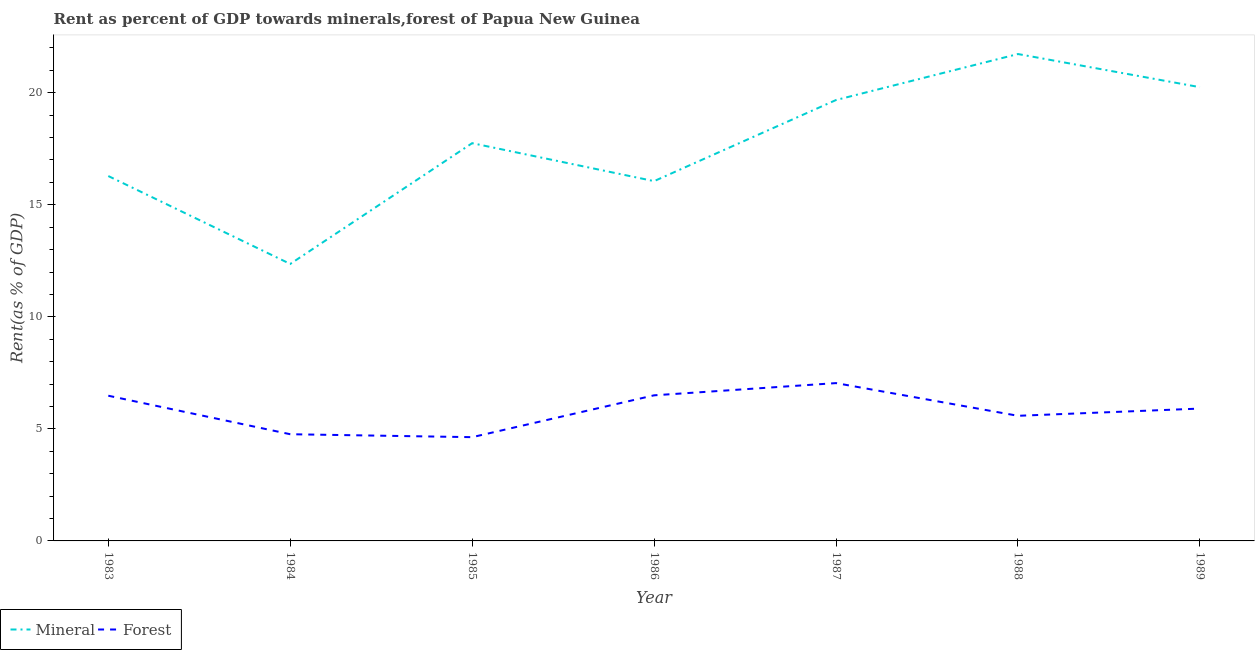How many different coloured lines are there?
Provide a succinct answer. 2. Does the line corresponding to mineral rent intersect with the line corresponding to forest rent?
Your response must be concise. No. Is the number of lines equal to the number of legend labels?
Your response must be concise. Yes. What is the forest rent in 1988?
Give a very brief answer. 5.58. Across all years, what is the maximum mineral rent?
Your answer should be compact. 21.73. Across all years, what is the minimum forest rent?
Give a very brief answer. 4.63. In which year was the mineral rent minimum?
Ensure brevity in your answer.  1984. What is the total mineral rent in the graph?
Offer a very short reply. 124.1. What is the difference between the mineral rent in 1985 and that in 1988?
Make the answer very short. -3.98. What is the difference between the forest rent in 1989 and the mineral rent in 1984?
Your answer should be compact. -6.45. What is the average mineral rent per year?
Your response must be concise. 17.73. In the year 1983, what is the difference between the forest rent and mineral rent?
Provide a succinct answer. -9.8. In how many years, is the forest rent greater than 6 %?
Ensure brevity in your answer.  3. What is the ratio of the forest rent in 1988 to that in 1989?
Ensure brevity in your answer.  0.95. What is the difference between the highest and the second highest mineral rent?
Provide a short and direct response. 1.48. What is the difference between the highest and the lowest mineral rent?
Offer a very short reply. 9.37. Does the forest rent monotonically increase over the years?
Make the answer very short. No. Is the forest rent strictly greater than the mineral rent over the years?
Offer a very short reply. No. Is the forest rent strictly less than the mineral rent over the years?
Give a very brief answer. Yes. How many lines are there?
Make the answer very short. 2. How many years are there in the graph?
Your answer should be very brief. 7. What is the difference between two consecutive major ticks on the Y-axis?
Make the answer very short. 5. Are the values on the major ticks of Y-axis written in scientific E-notation?
Keep it short and to the point. No. Does the graph contain grids?
Make the answer very short. No. Where does the legend appear in the graph?
Provide a short and direct response. Bottom left. How many legend labels are there?
Give a very brief answer. 2. What is the title of the graph?
Your response must be concise. Rent as percent of GDP towards minerals,forest of Papua New Guinea. What is the label or title of the X-axis?
Offer a terse response. Year. What is the label or title of the Y-axis?
Ensure brevity in your answer.  Rent(as % of GDP). What is the Rent(as % of GDP) in Mineral in 1983?
Give a very brief answer. 16.28. What is the Rent(as % of GDP) in Forest in 1983?
Ensure brevity in your answer.  6.48. What is the Rent(as % of GDP) of Mineral in 1984?
Give a very brief answer. 12.36. What is the Rent(as % of GDP) of Forest in 1984?
Ensure brevity in your answer.  4.76. What is the Rent(as % of GDP) in Mineral in 1985?
Offer a very short reply. 17.75. What is the Rent(as % of GDP) in Forest in 1985?
Offer a terse response. 4.63. What is the Rent(as % of GDP) of Mineral in 1986?
Make the answer very short. 16.05. What is the Rent(as % of GDP) of Forest in 1986?
Provide a succinct answer. 6.5. What is the Rent(as % of GDP) of Mineral in 1987?
Your answer should be compact. 19.68. What is the Rent(as % of GDP) in Forest in 1987?
Offer a terse response. 7.04. What is the Rent(as % of GDP) of Mineral in 1988?
Your response must be concise. 21.73. What is the Rent(as % of GDP) in Forest in 1988?
Your response must be concise. 5.58. What is the Rent(as % of GDP) in Mineral in 1989?
Ensure brevity in your answer.  20.25. What is the Rent(as % of GDP) in Forest in 1989?
Offer a very short reply. 5.91. Across all years, what is the maximum Rent(as % of GDP) in Mineral?
Make the answer very short. 21.73. Across all years, what is the maximum Rent(as % of GDP) in Forest?
Make the answer very short. 7.04. Across all years, what is the minimum Rent(as % of GDP) of Mineral?
Your answer should be compact. 12.36. Across all years, what is the minimum Rent(as % of GDP) in Forest?
Offer a terse response. 4.63. What is the total Rent(as % of GDP) of Mineral in the graph?
Provide a succinct answer. 124.1. What is the total Rent(as % of GDP) of Forest in the graph?
Make the answer very short. 40.9. What is the difference between the Rent(as % of GDP) in Mineral in 1983 and that in 1984?
Offer a terse response. 3.92. What is the difference between the Rent(as % of GDP) of Forest in 1983 and that in 1984?
Ensure brevity in your answer.  1.72. What is the difference between the Rent(as % of GDP) in Mineral in 1983 and that in 1985?
Your answer should be very brief. -1.47. What is the difference between the Rent(as % of GDP) in Forest in 1983 and that in 1985?
Keep it short and to the point. 1.85. What is the difference between the Rent(as % of GDP) of Mineral in 1983 and that in 1986?
Provide a succinct answer. 0.23. What is the difference between the Rent(as % of GDP) of Forest in 1983 and that in 1986?
Give a very brief answer. -0.02. What is the difference between the Rent(as % of GDP) in Mineral in 1983 and that in 1987?
Your answer should be compact. -3.39. What is the difference between the Rent(as % of GDP) of Forest in 1983 and that in 1987?
Make the answer very short. -0.56. What is the difference between the Rent(as % of GDP) in Mineral in 1983 and that in 1988?
Make the answer very short. -5.44. What is the difference between the Rent(as % of GDP) in Forest in 1983 and that in 1988?
Provide a succinct answer. 0.9. What is the difference between the Rent(as % of GDP) in Mineral in 1983 and that in 1989?
Keep it short and to the point. -3.96. What is the difference between the Rent(as % of GDP) in Forest in 1983 and that in 1989?
Make the answer very short. 0.57. What is the difference between the Rent(as % of GDP) in Mineral in 1984 and that in 1985?
Your answer should be compact. -5.39. What is the difference between the Rent(as % of GDP) in Forest in 1984 and that in 1985?
Provide a short and direct response. 0.13. What is the difference between the Rent(as % of GDP) in Mineral in 1984 and that in 1986?
Offer a terse response. -3.7. What is the difference between the Rent(as % of GDP) in Forest in 1984 and that in 1986?
Keep it short and to the point. -1.74. What is the difference between the Rent(as % of GDP) of Mineral in 1984 and that in 1987?
Provide a short and direct response. -7.32. What is the difference between the Rent(as % of GDP) of Forest in 1984 and that in 1987?
Provide a succinct answer. -2.28. What is the difference between the Rent(as % of GDP) in Mineral in 1984 and that in 1988?
Offer a very short reply. -9.37. What is the difference between the Rent(as % of GDP) in Forest in 1984 and that in 1988?
Offer a terse response. -0.82. What is the difference between the Rent(as % of GDP) of Mineral in 1984 and that in 1989?
Make the answer very short. -7.89. What is the difference between the Rent(as % of GDP) in Forest in 1984 and that in 1989?
Your answer should be compact. -1.14. What is the difference between the Rent(as % of GDP) in Mineral in 1985 and that in 1986?
Your answer should be very brief. 1.69. What is the difference between the Rent(as % of GDP) of Forest in 1985 and that in 1986?
Provide a short and direct response. -1.87. What is the difference between the Rent(as % of GDP) in Mineral in 1985 and that in 1987?
Ensure brevity in your answer.  -1.93. What is the difference between the Rent(as % of GDP) in Forest in 1985 and that in 1987?
Keep it short and to the point. -2.41. What is the difference between the Rent(as % of GDP) of Mineral in 1985 and that in 1988?
Your answer should be compact. -3.98. What is the difference between the Rent(as % of GDP) of Forest in 1985 and that in 1988?
Your answer should be very brief. -0.95. What is the difference between the Rent(as % of GDP) in Mineral in 1985 and that in 1989?
Provide a short and direct response. -2.5. What is the difference between the Rent(as % of GDP) of Forest in 1985 and that in 1989?
Ensure brevity in your answer.  -1.28. What is the difference between the Rent(as % of GDP) in Mineral in 1986 and that in 1987?
Give a very brief answer. -3.62. What is the difference between the Rent(as % of GDP) of Forest in 1986 and that in 1987?
Provide a succinct answer. -0.55. What is the difference between the Rent(as % of GDP) of Mineral in 1986 and that in 1988?
Ensure brevity in your answer.  -5.67. What is the difference between the Rent(as % of GDP) in Forest in 1986 and that in 1988?
Give a very brief answer. 0.91. What is the difference between the Rent(as % of GDP) of Mineral in 1986 and that in 1989?
Ensure brevity in your answer.  -4.19. What is the difference between the Rent(as % of GDP) in Forest in 1986 and that in 1989?
Your answer should be very brief. 0.59. What is the difference between the Rent(as % of GDP) in Mineral in 1987 and that in 1988?
Ensure brevity in your answer.  -2.05. What is the difference between the Rent(as % of GDP) of Forest in 1987 and that in 1988?
Offer a terse response. 1.46. What is the difference between the Rent(as % of GDP) in Mineral in 1987 and that in 1989?
Your answer should be compact. -0.57. What is the difference between the Rent(as % of GDP) of Forest in 1987 and that in 1989?
Ensure brevity in your answer.  1.14. What is the difference between the Rent(as % of GDP) in Mineral in 1988 and that in 1989?
Provide a succinct answer. 1.48. What is the difference between the Rent(as % of GDP) in Forest in 1988 and that in 1989?
Keep it short and to the point. -0.32. What is the difference between the Rent(as % of GDP) in Mineral in 1983 and the Rent(as % of GDP) in Forest in 1984?
Provide a succinct answer. 11.52. What is the difference between the Rent(as % of GDP) of Mineral in 1983 and the Rent(as % of GDP) of Forest in 1985?
Your answer should be compact. 11.65. What is the difference between the Rent(as % of GDP) in Mineral in 1983 and the Rent(as % of GDP) in Forest in 1986?
Your response must be concise. 9.79. What is the difference between the Rent(as % of GDP) of Mineral in 1983 and the Rent(as % of GDP) of Forest in 1987?
Offer a very short reply. 9.24. What is the difference between the Rent(as % of GDP) in Mineral in 1983 and the Rent(as % of GDP) in Forest in 1988?
Ensure brevity in your answer.  10.7. What is the difference between the Rent(as % of GDP) of Mineral in 1983 and the Rent(as % of GDP) of Forest in 1989?
Your answer should be very brief. 10.38. What is the difference between the Rent(as % of GDP) in Mineral in 1984 and the Rent(as % of GDP) in Forest in 1985?
Provide a succinct answer. 7.73. What is the difference between the Rent(as % of GDP) of Mineral in 1984 and the Rent(as % of GDP) of Forest in 1986?
Keep it short and to the point. 5.86. What is the difference between the Rent(as % of GDP) in Mineral in 1984 and the Rent(as % of GDP) in Forest in 1987?
Your answer should be compact. 5.32. What is the difference between the Rent(as % of GDP) of Mineral in 1984 and the Rent(as % of GDP) of Forest in 1988?
Your answer should be compact. 6.78. What is the difference between the Rent(as % of GDP) of Mineral in 1984 and the Rent(as % of GDP) of Forest in 1989?
Keep it short and to the point. 6.45. What is the difference between the Rent(as % of GDP) in Mineral in 1985 and the Rent(as % of GDP) in Forest in 1986?
Offer a terse response. 11.25. What is the difference between the Rent(as % of GDP) of Mineral in 1985 and the Rent(as % of GDP) of Forest in 1987?
Your answer should be compact. 10.71. What is the difference between the Rent(as % of GDP) in Mineral in 1985 and the Rent(as % of GDP) in Forest in 1988?
Keep it short and to the point. 12.17. What is the difference between the Rent(as % of GDP) of Mineral in 1985 and the Rent(as % of GDP) of Forest in 1989?
Offer a very short reply. 11.84. What is the difference between the Rent(as % of GDP) in Mineral in 1986 and the Rent(as % of GDP) in Forest in 1987?
Your response must be concise. 9.01. What is the difference between the Rent(as % of GDP) in Mineral in 1986 and the Rent(as % of GDP) in Forest in 1988?
Provide a short and direct response. 10.47. What is the difference between the Rent(as % of GDP) of Mineral in 1986 and the Rent(as % of GDP) of Forest in 1989?
Your response must be concise. 10.15. What is the difference between the Rent(as % of GDP) in Mineral in 1987 and the Rent(as % of GDP) in Forest in 1988?
Make the answer very short. 14.09. What is the difference between the Rent(as % of GDP) in Mineral in 1987 and the Rent(as % of GDP) in Forest in 1989?
Your answer should be compact. 13.77. What is the difference between the Rent(as % of GDP) of Mineral in 1988 and the Rent(as % of GDP) of Forest in 1989?
Keep it short and to the point. 15.82. What is the average Rent(as % of GDP) of Mineral per year?
Your answer should be very brief. 17.73. What is the average Rent(as % of GDP) of Forest per year?
Make the answer very short. 5.84. In the year 1983, what is the difference between the Rent(as % of GDP) of Mineral and Rent(as % of GDP) of Forest?
Offer a very short reply. 9.8. In the year 1984, what is the difference between the Rent(as % of GDP) of Mineral and Rent(as % of GDP) of Forest?
Ensure brevity in your answer.  7.6. In the year 1985, what is the difference between the Rent(as % of GDP) in Mineral and Rent(as % of GDP) in Forest?
Your answer should be compact. 13.12. In the year 1986, what is the difference between the Rent(as % of GDP) of Mineral and Rent(as % of GDP) of Forest?
Make the answer very short. 9.56. In the year 1987, what is the difference between the Rent(as % of GDP) of Mineral and Rent(as % of GDP) of Forest?
Your answer should be compact. 12.63. In the year 1988, what is the difference between the Rent(as % of GDP) in Mineral and Rent(as % of GDP) in Forest?
Your answer should be compact. 16.14. In the year 1989, what is the difference between the Rent(as % of GDP) of Mineral and Rent(as % of GDP) of Forest?
Ensure brevity in your answer.  14.34. What is the ratio of the Rent(as % of GDP) in Mineral in 1983 to that in 1984?
Your answer should be compact. 1.32. What is the ratio of the Rent(as % of GDP) in Forest in 1983 to that in 1984?
Provide a short and direct response. 1.36. What is the ratio of the Rent(as % of GDP) in Mineral in 1983 to that in 1985?
Your answer should be very brief. 0.92. What is the ratio of the Rent(as % of GDP) in Forest in 1983 to that in 1985?
Provide a short and direct response. 1.4. What is the ratio of the Rent(as % of GDP) in Mineral in 1983 to that in 1986?
Your answer should be compact. 1.01. What is the ratio of the Rent(as % of GDP) of Mineral in 1983 to that in 1987?
Offer a very short reply. 0.83. What is the ratio of the Rent(as % of GDP) of Forest in 1983 to that in 1987?
Your answer should be very brief. 0.92. What is the ratio of the Rent(as % of GDP) in Mineral in 1983 to that in 1988?
Provide a short and direct response. 0.75. What is the ratio of the Rent(as % of GDP) of Forest in 1983 to that in 1988?
Make the answer very short. 1.16. What is the ratio of the Rent(as % of GDP) in Mineral in 1983 to that in 1989?
Make the answer very short. 0.8. What is the ratio of the Rent(as % of GDP) of Forest in 1983 to that in 1989?
Ensure brevity in your answer.  1.1. What is the ratio of the Rent(as % of GDP) of Mineral in 1984 to that in 1985?
Keep it short and to the point. 0.7. What is the ratio of the Rent(as % of GDP) of Forest in 1984 to that in 1985?
Make the answer very short. 1.03. What is the ratio of the Rent(as % of GDP) of Mineral in 1984 to that in 1986?
Your answer should be compact. 0.77. What is the ratio of the Rent(as % of GDP) in Forest in 1984 to that in 1986?
Ensure brevity in your answer.  0.73. What is the ratio of the Rent(as % of GDP) of Mineral in 1984 to that in 1987?
Offer a very short reply. 0.63. What is the ratio of the Rent(as % of GDP) in Forest in 1984 to that in 1987?
Provide a short and direct response. 0.68. What is the ratio of the Rent(as % of GDP) in Mineral in 1984 to that in 1988?
Provide a short and direct response. 0.57. What is the ratio of the Rent(as % of GDP) of Forest in 1984 to that in 1988?
Provide a succinct answer. 0.85. What is the ratio of the Rent(as % of GDP) in Mineral in 1984 to that in 1989?
Your response must be concise. 0.61. What is the ratio of the Rent(as % of GDP) of Forest in 1984 to that in 1989?
Keep it short and to the point. 0.81. What is the ratio of the Rent(as % of GDP) of Mineral in 1985 to that in 1986?
Ensure brevity in your answer.  1.11. What is the ratio of the Rent(as % of GDP) of Forest in 1985 to that in 1986?
Give a very brief answer. 0.71. What is the ratio of the Rent(as % of GDP) in Mineral in 1985 to that in 1987?
Your answer should be compact. 0.9. What is the ratio of the Rent(as % of GDP) of Forest in 1985 to that in 1987?
Make the answer very short. 0.66. What is the ratio of the Rent(as % of GDP) of Mineral in 1985 to that in 1988?
Provide a succinct answer. 0.82. What is the ratio of the Rent(as % of GDP) in Forest in 1985 to that in 1988?
Provide a succinct answer. 0.83. What is the ratio of the Rent(as % of GDP) of Mineral in 1985 to that in 1989?
Provide a short and direct response. 0.88. What is the ratio of the Rent(as % of GDP) of Forest in 1985 to that in 1989?
Ensure brevity in your answer.  0.78. What is the ratio of the Rent(as % of GDP) of Mineral in 1986 to that in 1987?
Provide a succinct answer. 0.82. What is the ratio of the Rent(as % of GDP) in Forest in 1986 to that in 1987?
Offer a terse response. 0.92. What is the ratio of the Rent(as % of GDP) of Mineral in 1986 to that in 1988?
Make the answer very short. 0.74. What is the ratio of the Rent(as % of GDP) of Forest in 1986 to that in 1988?
Provide a short and direct response. 1.16. What is the ratio of the Rent(as % of GDP) in Mineral in 1986 to that in 1989?
Your answer should be very brief. 0.79. What is the ratio of the Rent(as % of GDP) of Forest in 1986 to that in 1989?
Provide a short and direct response. 1.1. What is the ratio of the Rent(as % of GDP) of Mineral in 1987 to that in 1988?
Keep it short and to the point. 0.91. What is the ratio of the Rent(as % of GDP) of Forest in 1987 to that in 1988?
Provide a succinct answer. 1.26. What is the ratio of the Rent(as % of GDP) of Mineral in 1987 to that in 1989?
Offer a very short reply. 0.97. What is the ratio of the Rent(as % of GDP) in Forest in 1987 to that in 1989?
Your answer should be compact. 1.19. What is the ratio of the Rent(as % of GDP) of Mineral in 1988 to that in 1989?
Provide a succinct answer. 1.07. What is the ratio of the Rent(as % of GDP) in Forest in 1988 to that in 1989?
Give a very brief answer. 0.95. What is the difference between the highest and the second highest Rent(as % of GDP) in Mineral?
Provide a short and direct response. 1.48. What is the difference between the highest and the second highest Rent(as % of GDP) in Forest?
Your answer should be compact. 0.55. What is the difference between the highest and the lowest Rent(as % of GDP) of Mineral?
Provide a succinct answer. 9.37. What is the difference between the highest and the lowest Rent(as % of GDP) of Forest?
Offer a terse response. 2.41. 